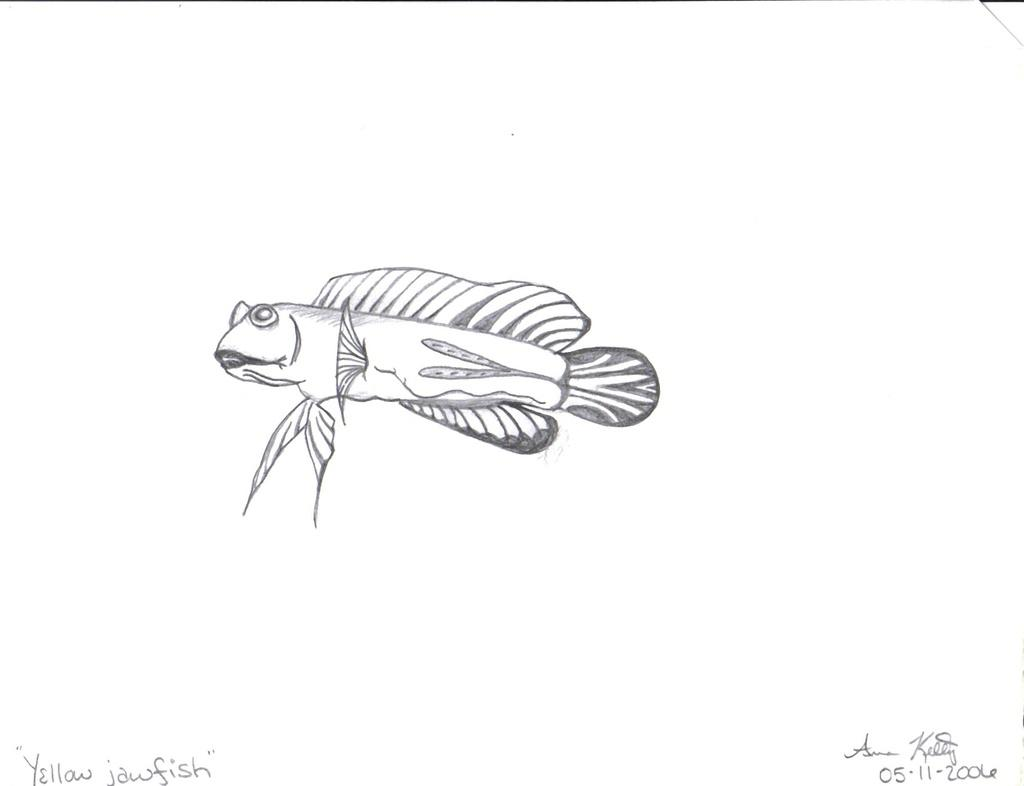What is the main subject of the image? The main subject of the image is a sketch. Can you describe the sketch in the image? Unfortunately, the sketch cannot be described in detail without more information about its content. What else is present in the image besides the sketch? There is written text in the bottom left of the image. What type of bead is being used for teaching in the image? There is no bead or teaching activity present in the image; it only contains a sketch and written text. 